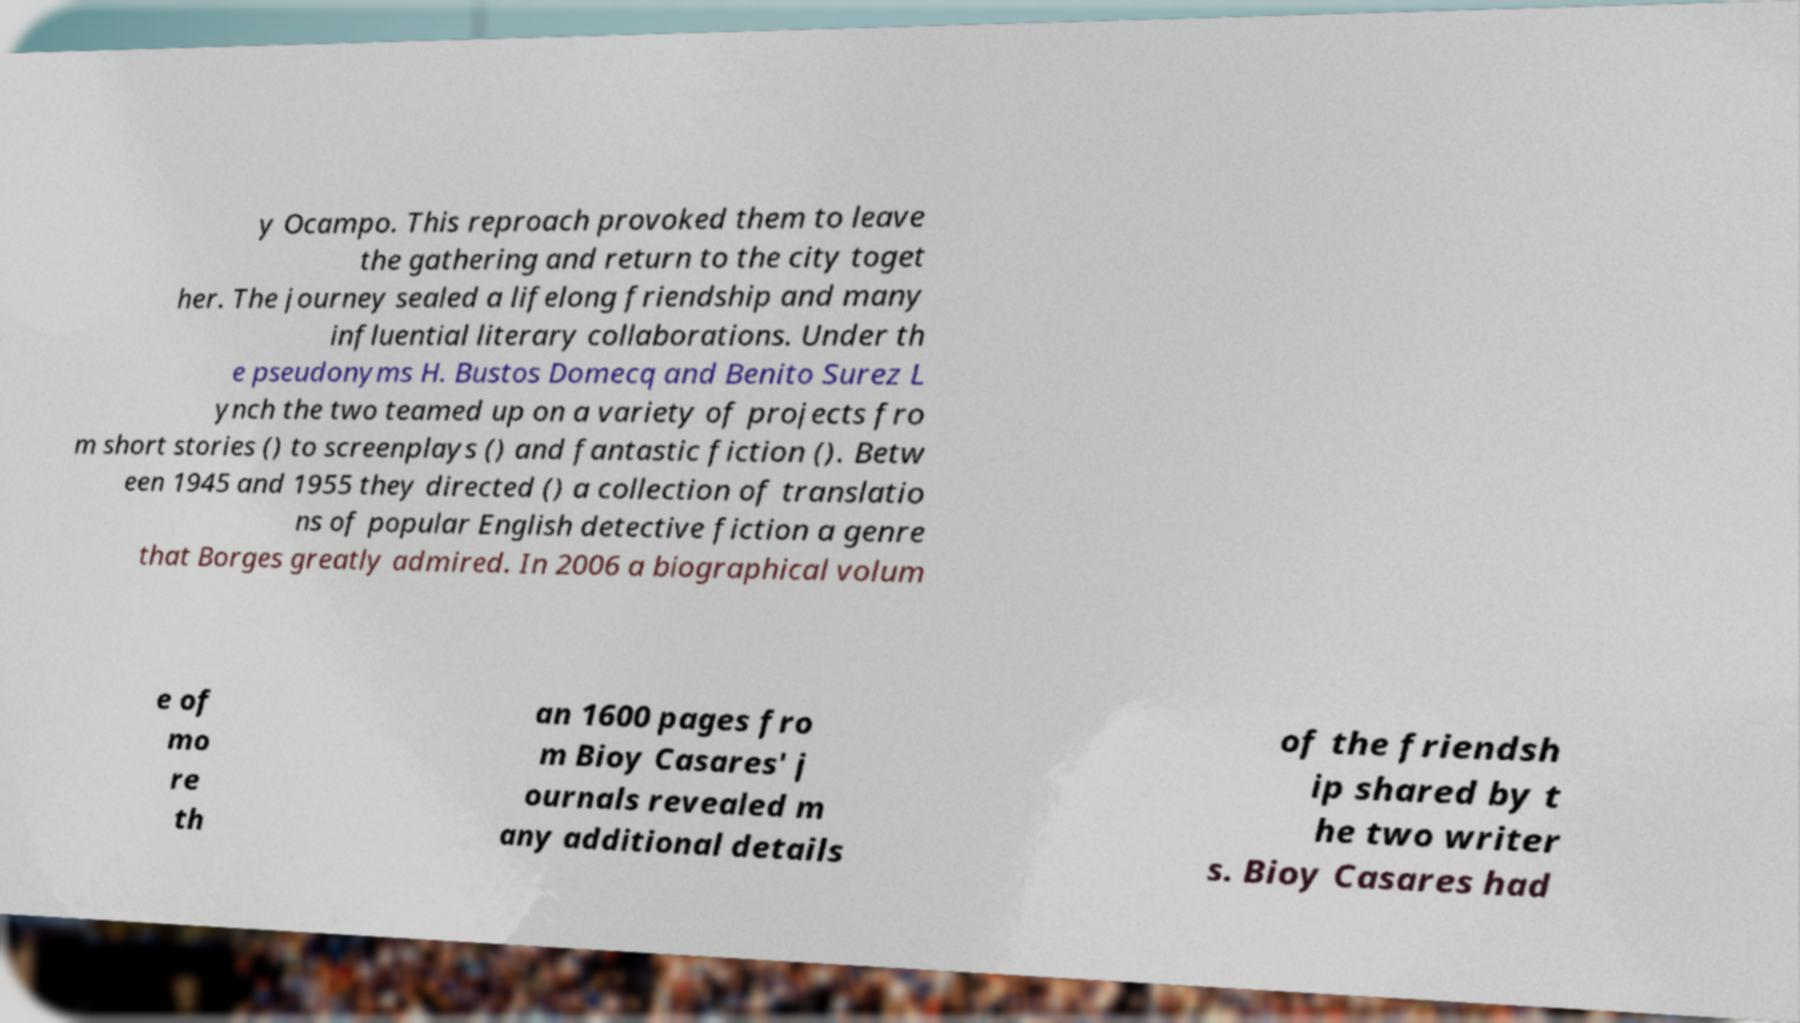Can you accurately transcribe the text from the provided image for me? y Ocampo. This reproach provoked them to leave the gathering and return to the city toget her. The journey sealed a lifelong friendship and many influential literary collaborations. Under th e pseudonyms H. Bustos Domecq and Benito Surez L ynch the two teamed up on a variety of projects fro m short stories () to screenplays () and fantastic fiction (). Betw een 1945 and 1955 they directed () a collection of translatio ns of popular English detective fiction a genre that Borges greatly admired. In 2006 a biographical volum e of mo re th an 1600 pages fro m Bioy Casares' j ournals revealed m any additional details of the friendsh ip shared by t he two writer s. Bioy Casares had 